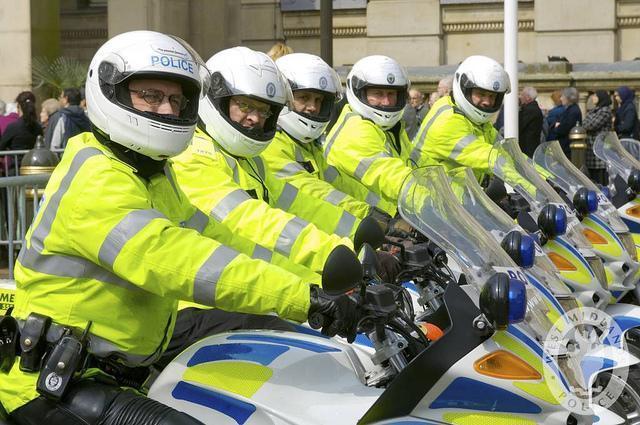How many people are there?
Give a very brief answer. 5. How many motorcycles are there?
Give a very brief answer. 5. 